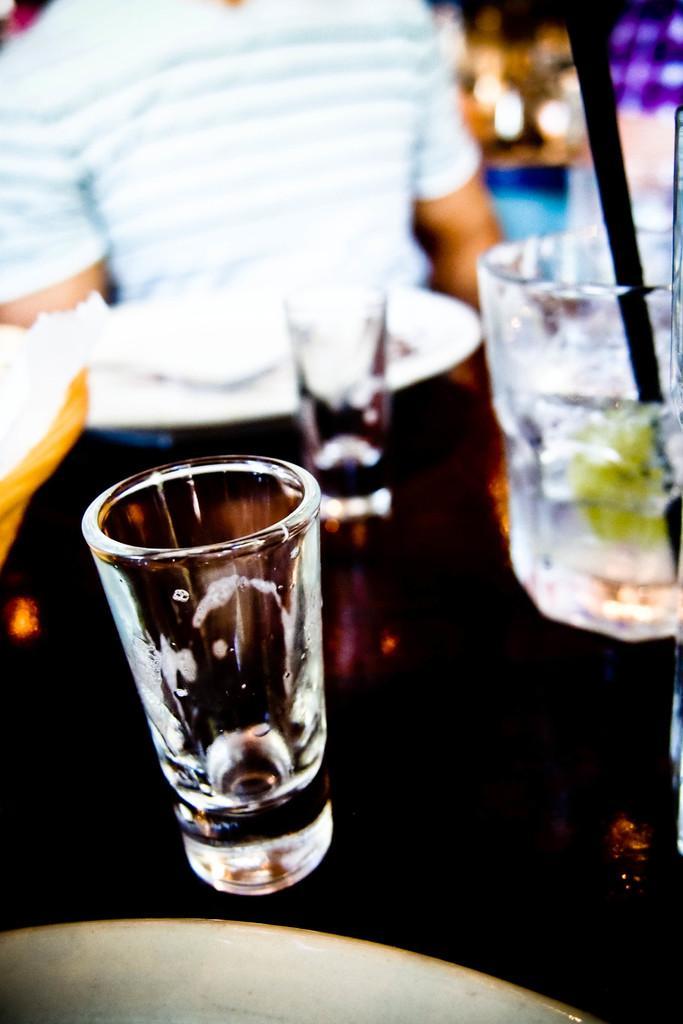How would you summarize this image in a sentence or two? Here I can see few glasses. It seems to be a glass is falling down. At the bottom there is a wooden object. In the background a person is standing and holding a plate. The background is blurred. 